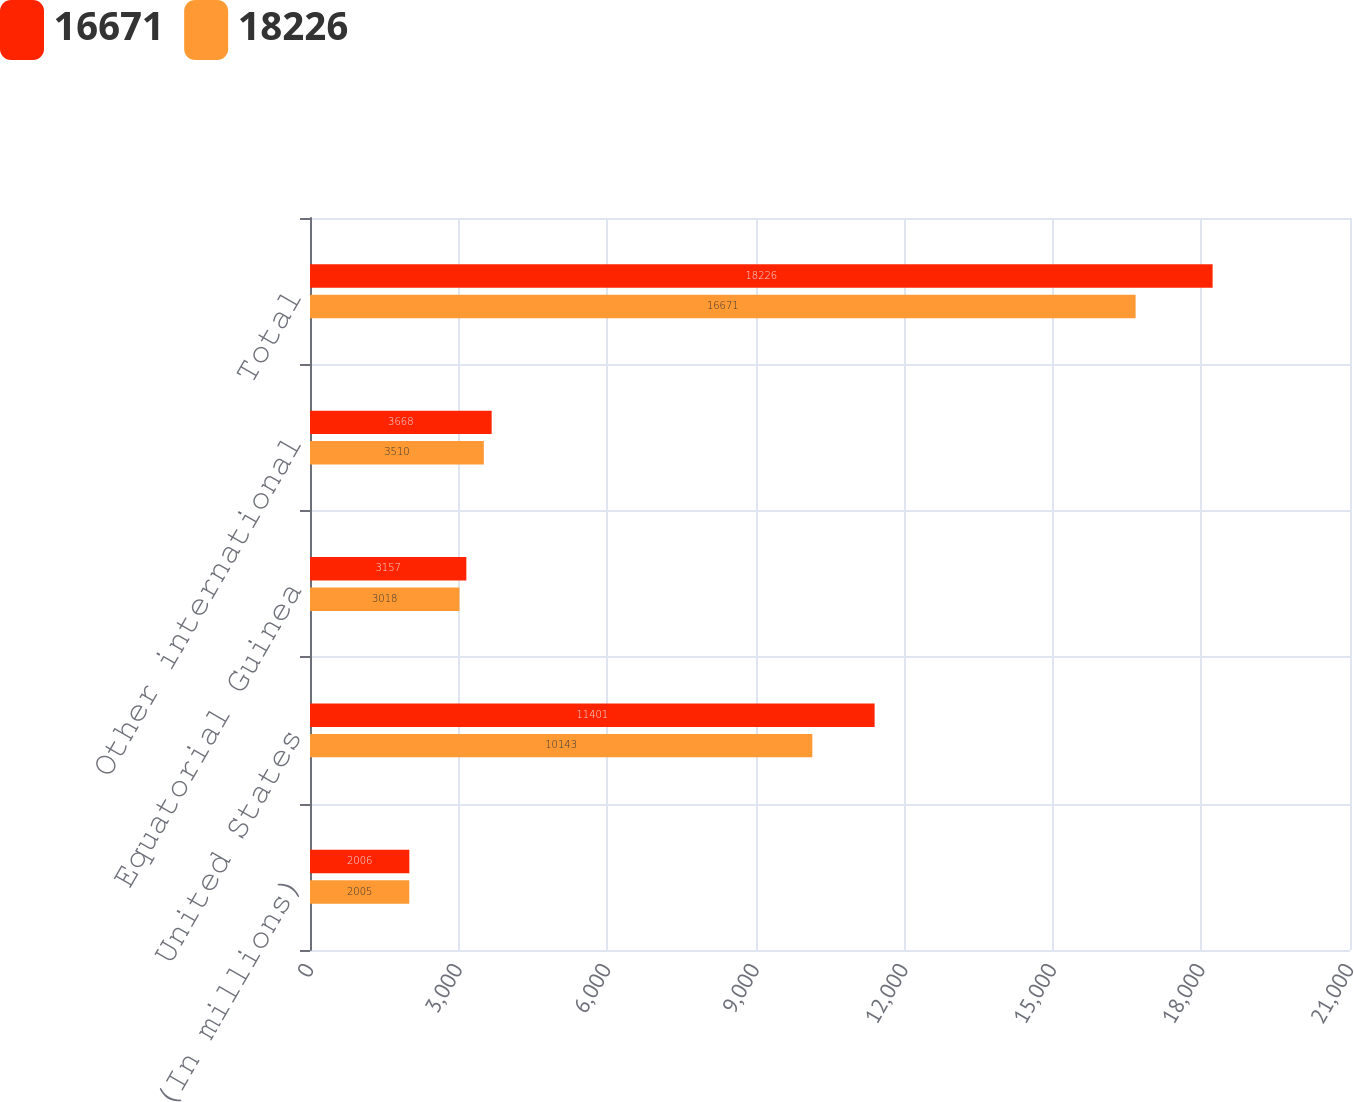Convert chart. <chart><loc_0><loc_0><loc_500><loc_500><stacked_bar_chart><ecel><fcel>(In millions)<fcel>United States<fcel>Equatorial Guinea<fcel>Other international<fcel>Total<nl><fcel>16671<fcel>2006<fcel>11401<fcel>3157<fcel>3668<fcel>18226<nl><fcel>18226<fcel>2005<fcel>10143<fcel>3018<fcel>3510<fcel>16671<nl></chart> 